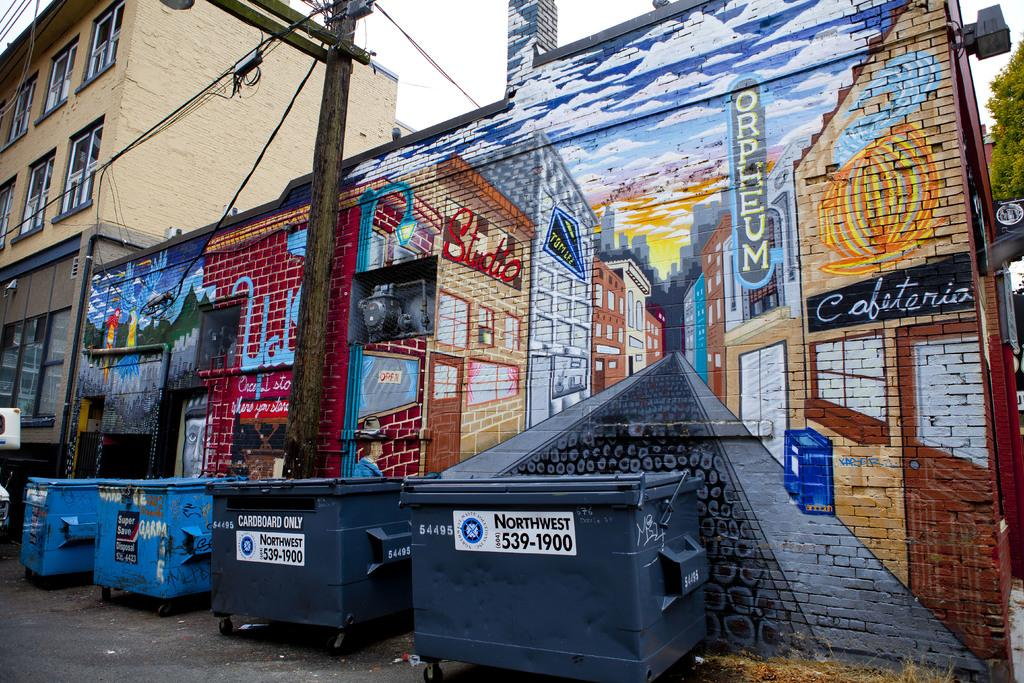<image>
Provide a brief description of the given image. a mural advertising Orpheum and a cafeteria is lined with dumpsters 